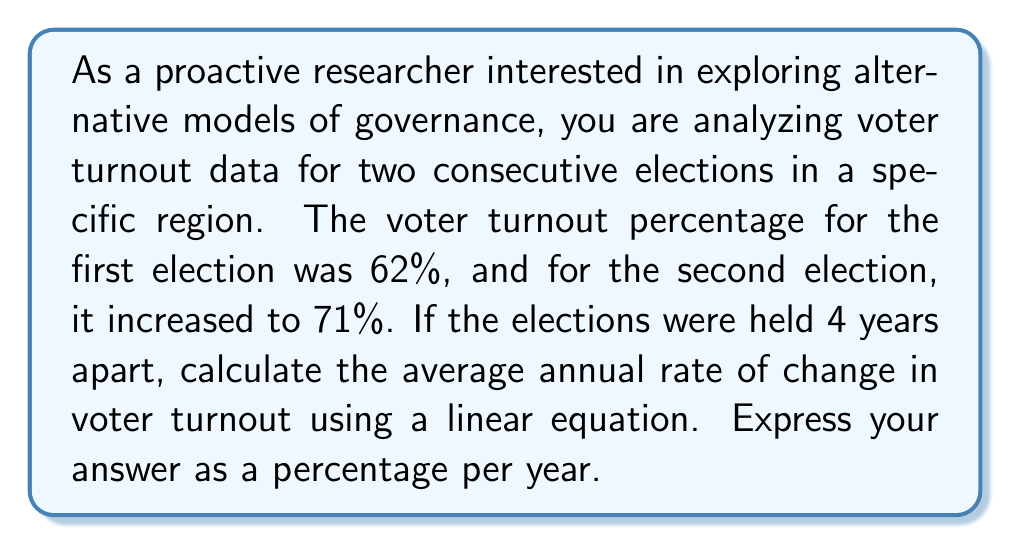Can you answer this question? To solve this problem, we'll use the concept of linear equations and rate of change. Let's break it down step by step:

1) First, let's define our variables:
   $x$ = time in years
   $y$ = voter turnout percentage

2) We have two data points:
   $(x_1, y_1) = (0, 62)$ (first election)
   $(x_2, y_2) = (4, 71)$ (second election)

3) The rate of change (slope) formula is:

   $$m = \frac{y_2 - y_1}{x_2 - x_1}$$

4) Let's substitute our values:

   $$m = \frac{71 - 62}{4 - 0} = \frac{9}{4} = 2.25$$

5) This means the voter turnout increased by 2.25 percentage points per year on average.

6) To express this as a percentage per year, we can simply write it as 2.25%.

The linear equation for this scenario would be:

$$y = 2.25x + 62$$

Where $y$ is the voter turnout percentage and $x$ is the number of years since the first election.
Answer: The average annual rate of change in voter turnout is 2.25% per year. 